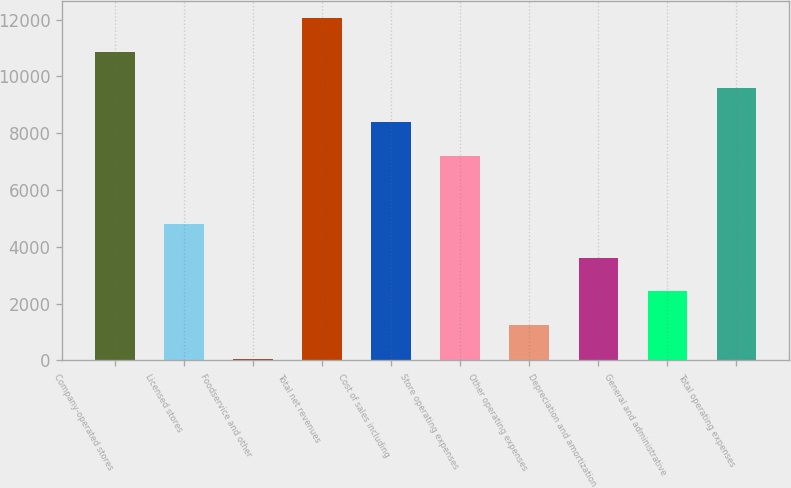Convert chart to OTSL. <chart><loc_0><loc_0><loc_500><loc_500><bar_chart><fcel>Company-operated stores<fcel>Licensed stores<fcel>Foodservice and other<fcel>Total net revenues<fcel>Cost of sales including<fcel>Store operating expenses<fcel>Other operating expenses<fcel>Depreciation and amortization<fcel>General and administrative<fcel>Total operating expenses<nl><fcel>10866.5<fcel>4815.66<fcel>39.1<fcel>12060.6<fcel>8398.08<fcel>7203.94<fcel>1233.24<fcel>3621.52<fcel>2427.38<fcel>9592.22<nl></chart> 